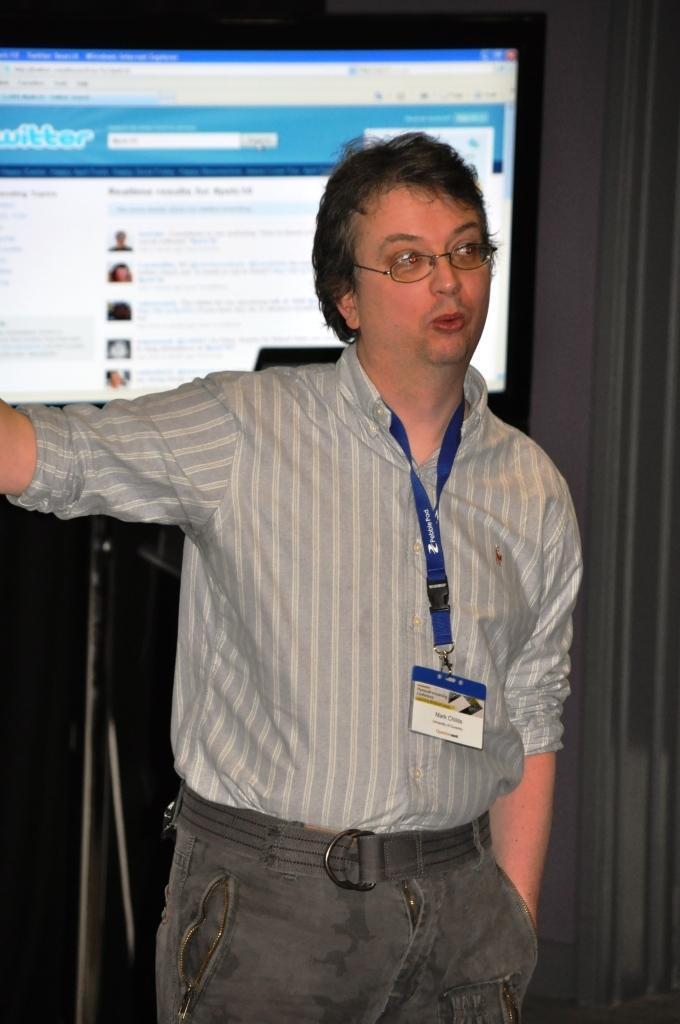Could you give a brief overview of what you see in this image? The man in front of the picture who is wearing a grey shirt and an ID card is standing. He is wearing the spectacles and I think he is talking something. Behind him, we see a stand. On the right side, we see a white wall. In the background, we see a projector screen which is displaying some text. 